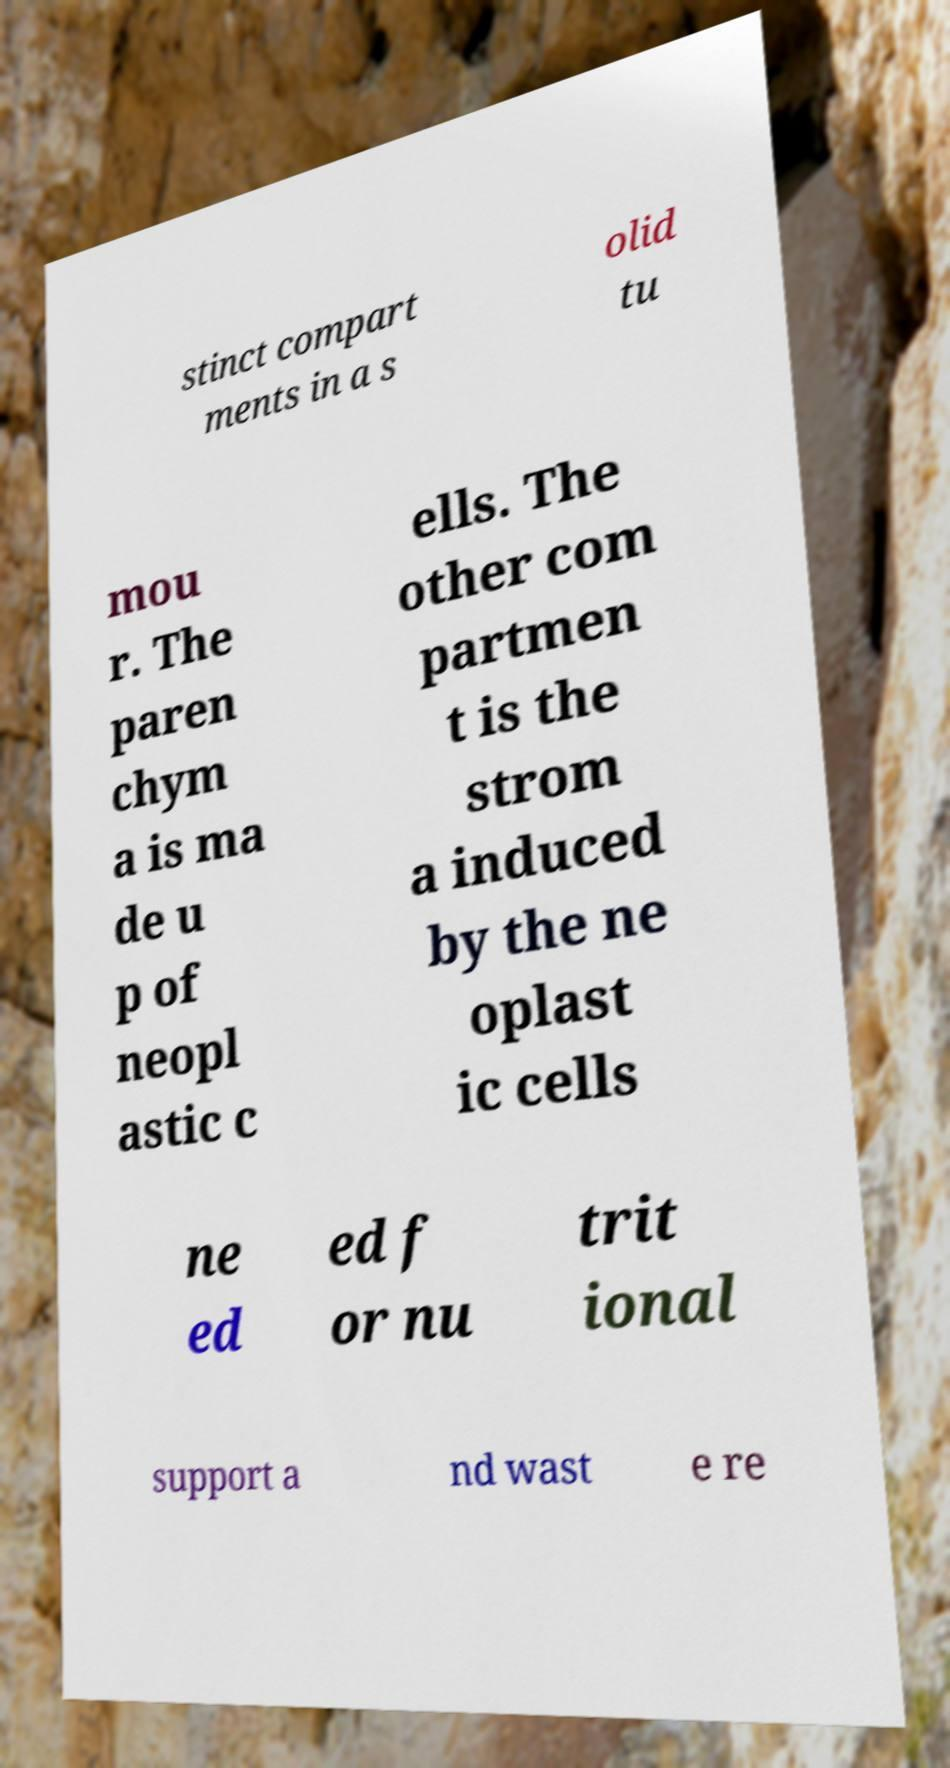Can you accurately transcribe the text from the provided image for me? stinct compart ments in a s olid tu mou r. The paren chym a is ma de u p of neopl astic c ells. The other com partmen t is the strom a induced by the ne oplast ic cells ne ed ed f or nu trit ional support a nd wast e re 